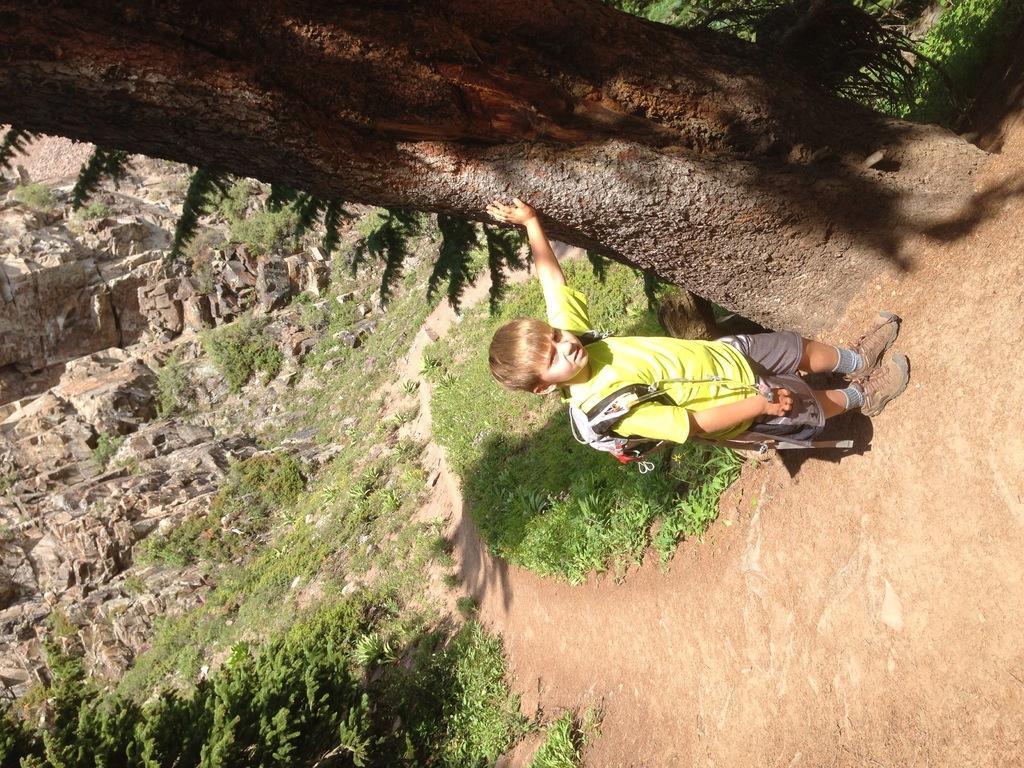Could you give a brief overview of what you see in this image? In this image there is a boy wearing a bag and standing, there is a tree truncated, there is grass, there are plants, there are rocks. 